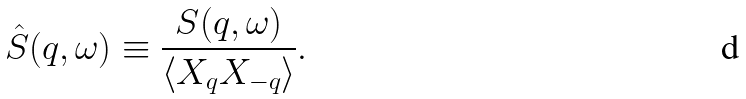<formula> <loc_0><loc_0><loc_500><loc_500>\hat { S } ( { q } , \omega ) \equiv \frac { S ( { q } , \omega ) } { \langle X _ { q } X _ { - { q } } \rangle } .</formula> 